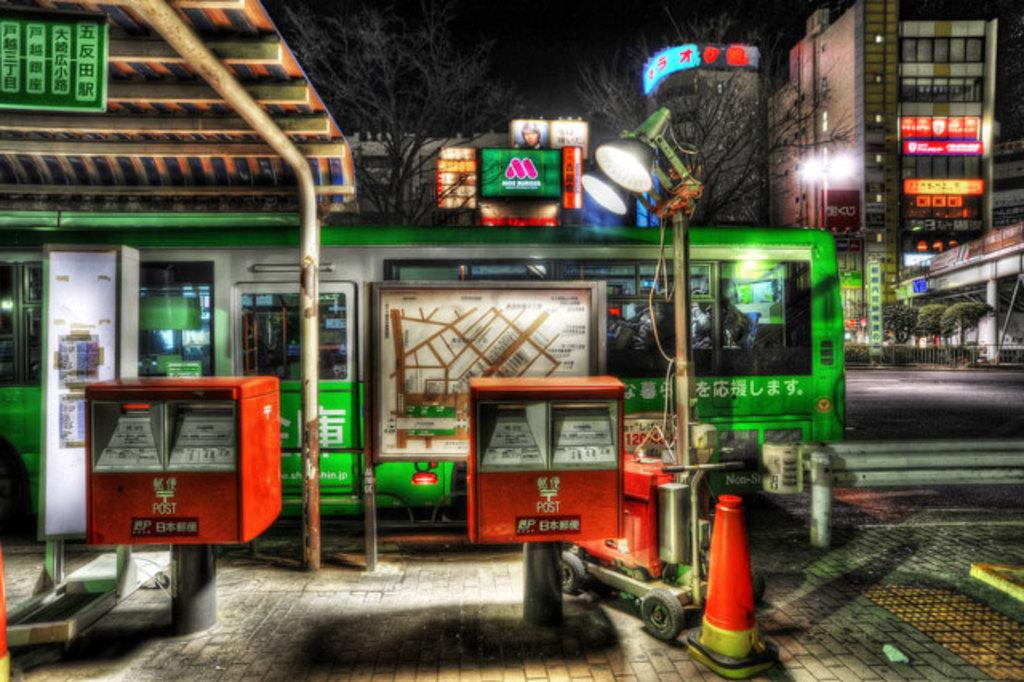Provide a one-sentence caption for the provided image. Red square stands that say POST on it. 